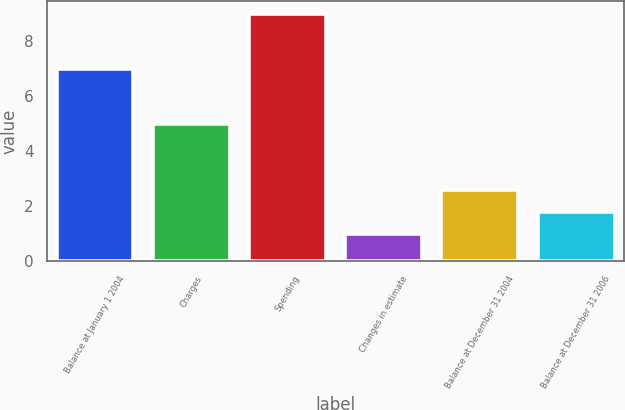Convert chart to OTSL. <chart><loc_0><loc_0><loc_500><loc_500><bar_chart><fcel>Balance at January 1 2004<fcel>Charges<fcel>Spending<fcel>Changes in estimate<fcel>Balance at December 31 2004<fcel>Balance at December 31 2006<nl><fcel>7<fcel>5<fcel>9<fcel>1<fcel>2.6<fcel>1.8<nl></chart> 